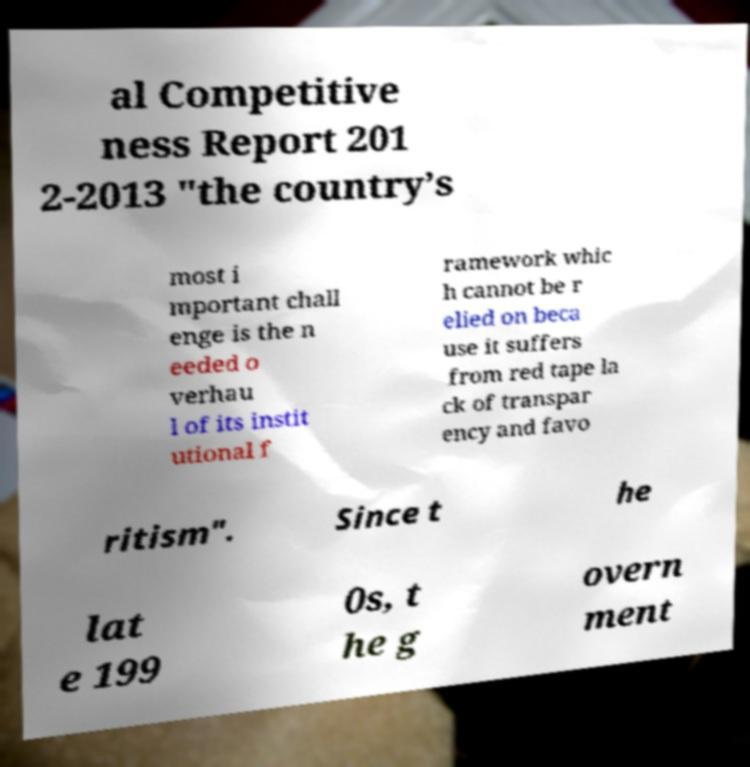Please identify and transcribe the text found in this image. al Competitive ness Report 201 2-2013 "the country’s most i mportant chall enge is the n eeded o verhau l of its instit utional f ramework whic h cannot be r elied on beca use it suffers from red tape la ck of transpar ency and favo ritism". Since t he lat e 199 0s, t he g overn ment 